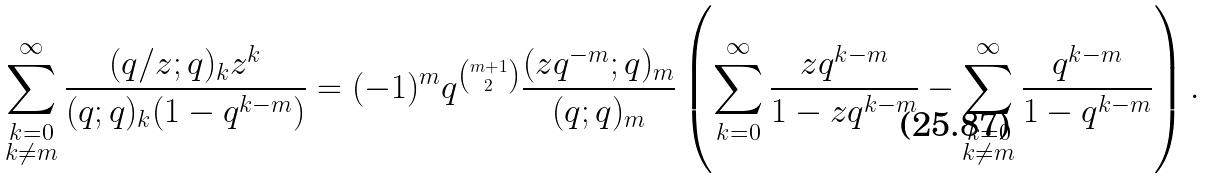Convert formula to latex. <formula><loc_0><loc_0><loc_500><loc_500>\sum _ { \substack { k = 0 \\ k \neq m } } ^ { \infty } \frac { ( q / z ; q ) _ { k } z ^ { k } } { ( q ; q ) _ { k } ( 1 - q ^ { k - m } ) } = ( - 1 ) ^ { m } q ^ { m + 1 \choose 2 } \frac { ( z q ^ { - m } ; q ) _ { m } } { ( q ; q ) _ { m } } \left ( \sum _ { k = 0 } ^ { \infty } \frac { z q ^ { k - m } } { 1 - z q ^ { k - m } } - \sum _ { \substack { k = 0 \\ k \neq m } } ^ { \infty } \frac { q ^ { k - m } } { 1 - q ^ { k - m } } \right ) .</formula> 